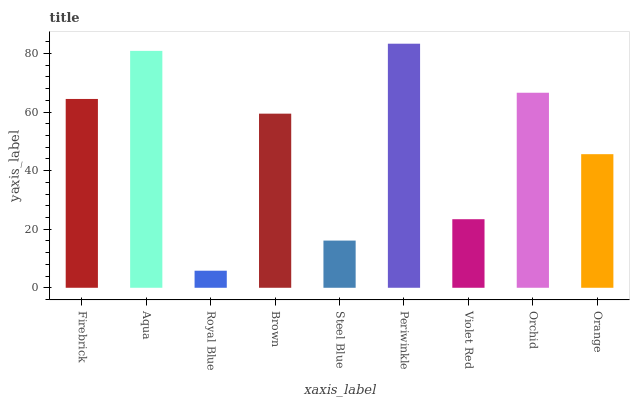Is Aqua the minimum?
Answer yes or no. No. Is Aqua the maximum?
Answer yes or no. No. Is Aqua greater than Firebrick?
Answer yes or no. Yes. Is Firebrick less than Aqua?
Answer yes or no. Yes. Is Firebrick greater than Aqua?
Answer yes or no. No. Is Aqua less than Firebrick?
Answer yes or no. No. Is Brown the high median?
Answer yes or no. Yes. Is Brown the low median?
Answer yes or no. Yes. Is Firebrick the high median?
Answer yes or no. No. Is Firebrick the low median?
Answer yes or no. No. 